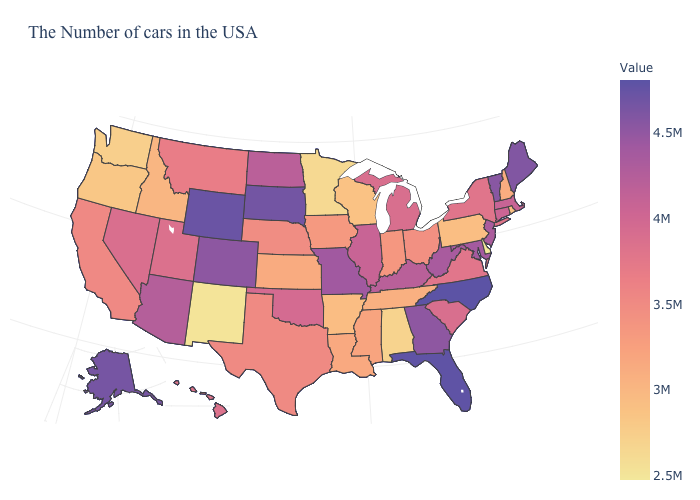Is the legend a continuous bar?
Quick response, please. Yes. Among the states that border West Virginia , which have the lowest value?
Be succinct. Pennsylvania. Among the states that border Vermont , does Massachusetts have the lowest value?
Quick response, please. No. 